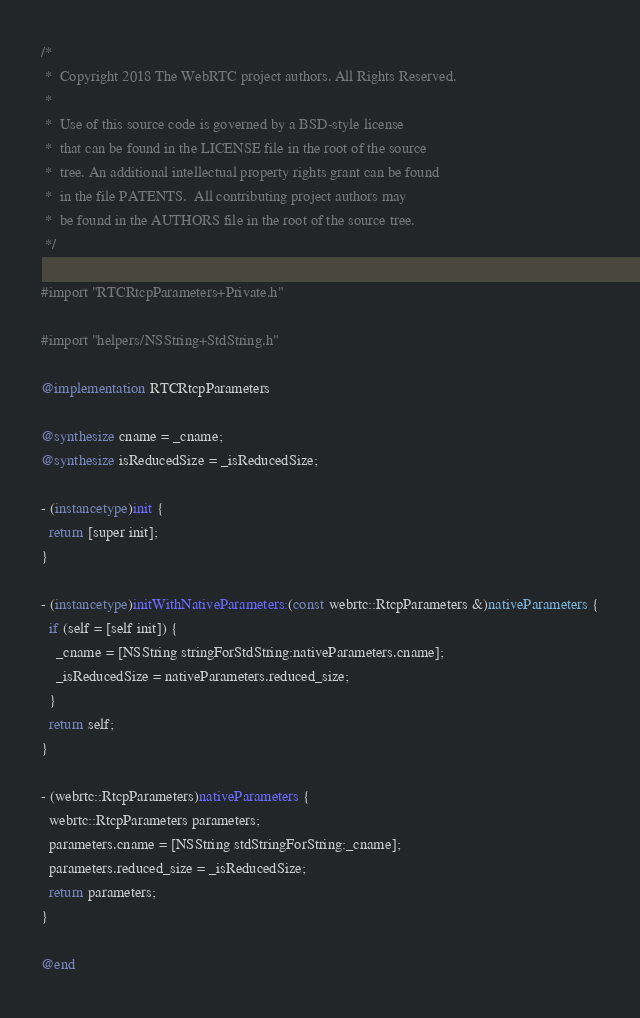<code> <loc_0><loc_0><loc_500><loc_500><_ObjectiveC_>/*
 *  Copyright 2018 The WebRTC project authors. All Rights Reserved.
 *
 *  Use of this source code is governed by a BSD-style license
 *  that can be found in the LICENSE file in the root of the source
 *  tree. An additional intellectual property rights grant can be found
 *  in the file PATENTS.  All contributing project authors may
 *  be found in the AUTHORS file in the root of the source tree.
 */

#import "RTCRtcpParameters+Private.h"

#import "helpers/NSString+StdString.h"

@implementation RTCRtcpParameters

@synthesize cname = _cname;
@synthesize isReducedSize = _isReducedSize;

- (instancetype)init {
  return [super init];
}

- (instancetype)initWithNativeParameters:(const webrtc::RtcpParameters &)nativeParameters {
  if (self = [self init]) {
    _cname = [NSString stringForStdString:nativeParameters.cname];
    _isReducedSize = nativeParameters.reduced_size;
  }
  return self;
}

- (webrtc::RtcpParameters)nativeParameters {
  webrtc::RtcpParameters parameters;
  parameters.cname = [NSString stdStringForString:_cname];
  parameters.reduced_size = _isReducedSize;
  return parameters;
}

@end
</code> 